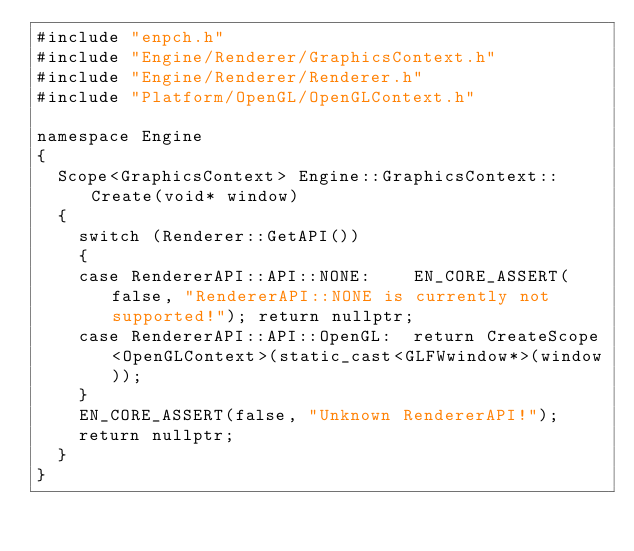<code> <loc_0><loc_0><loc_500><loc_500><_C++_>#include "enpch.h"
#include "Engine/Renderer/GraphicsContext.h"
#include "Engine/Renderer/Renderer.h"
#include "Platform/OpenGL/OpenGLContext.h"

namespace Engine
{
  Scope<GraphicsContext> Engine::GraphicsContext::Create(void* window)
  {
    switch (Renderer::GetAPI())
    {
    case RendererAPI::API::NONE:    EN_CORE_ASSERT(false, "RendererAPI::NONE is currently not supported!"); return nullptr;
    case RendererAPI::API::OpenGL:  return CreateScope<OpenGLContext>(static_cast<GLFWwindow*>(window));
    }
    EN_CORE_ASSERT(false, "Unknown RendererAPI!");
    return nullptr;
  }
}</code> 